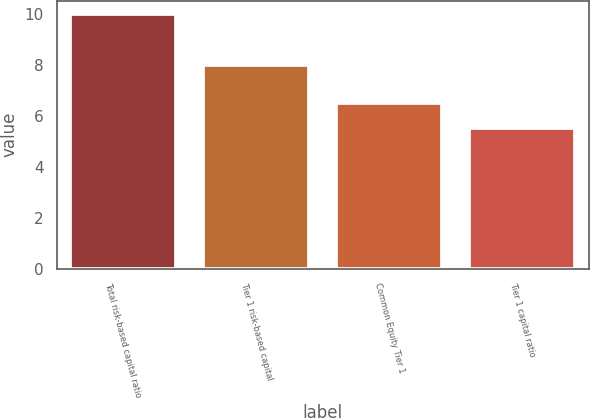<chart> <loc_0><loc_0><loc_500><loc_500><bar_chart><fcel>Total risk-based capital ratio<fcel>Tier 1 risk-based capital<fcel>Common Equity Tier 1<fcel>Tier 1 capital ratio<nl><fcel>10<fcel>8<fcel>6.5<fcel>5.5<nl></chart> 